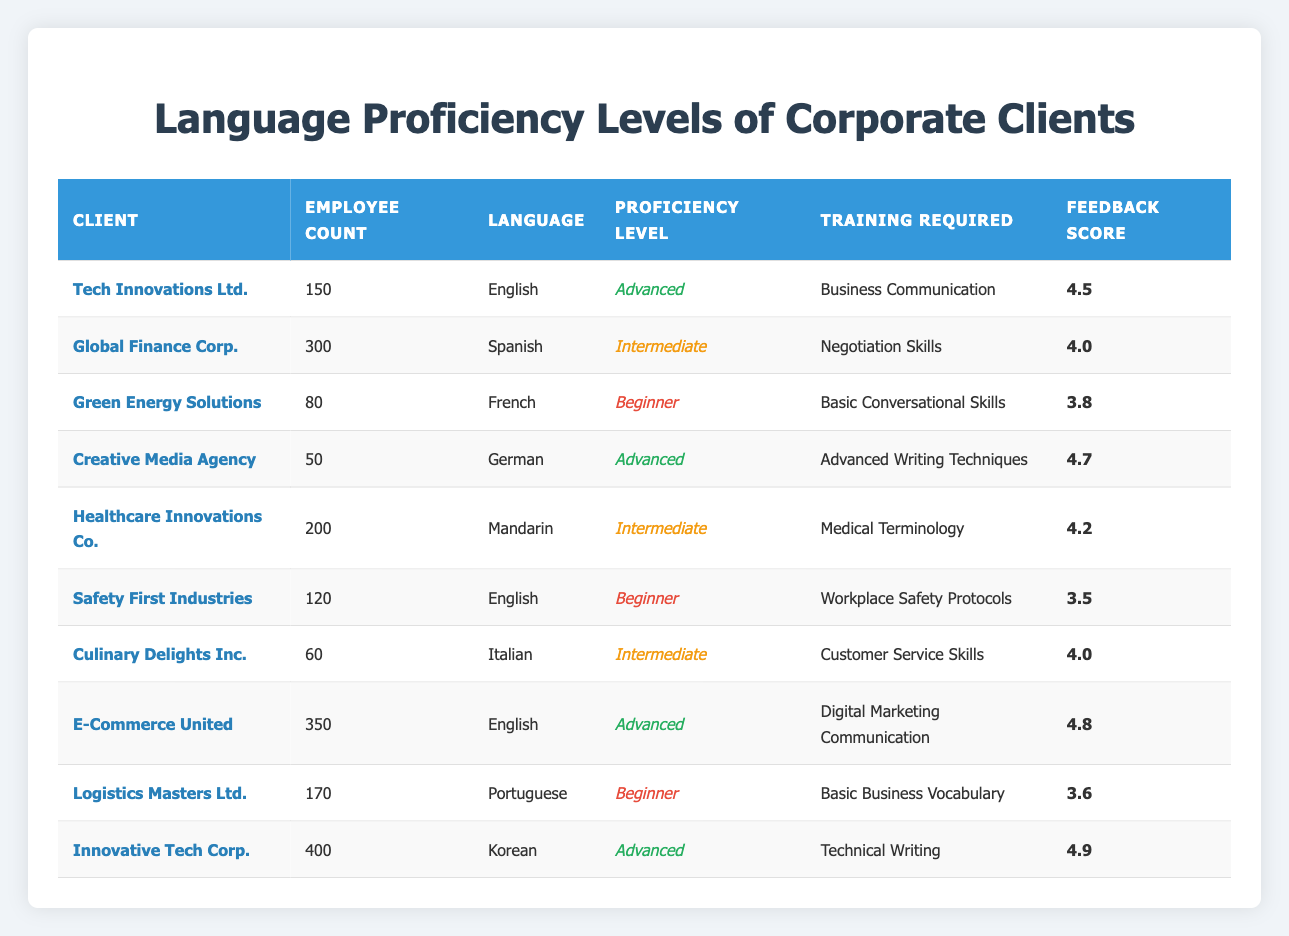What is the highest feedback score recorded in the table? Upon reviewing the feedback scores, the highest value listed is 4.9, which corresponds to Innovative Tech Corp. The scores are: 4.5, 4.0, 3.8, 4.7, 4.2, 3.5, 4.0, 4.8, 3.6, and 4.9. The maximum score among these is 4.9.
Answer: 4.9 How many clients require training for a beginner proficiency level? To determine how many clients have a beginner proficiency level, I check the proficiency levels listed for each client. The clients with a beginner proficiency are Green Energy Solutions, Safety First Industries, and Logistics Masters Ltd. That totals three clients.
Answer: 3 What is the average employee count for clients with advanced proficiency levels? The clients with advanced proficiency levels are Tech Innovations Ltd. (150), Creative Media Agency (50), E-Commerce United (350), and Innovative Tech Corp. (400). Adding these employee counts gives 150 + 50 + 350 + 400 = 950. To find the average, divide by the number of clients, which is 4. Thus, the average is 950 / 4 = 237.5.
Answer: 237.5 Is there a client whose feedback score is below 4.0? Reviewing the feedback scores, we find scores of 3.5 and 3.6 for Safety First Industries and Logistics Masters Ltd., respectively, which are both below 4.0. Therefore, the statement is true.
Answer: Yes Which language requires training on Medical Terminology, and what is the proficiency level of the corresponding client? The training required on Medical Terminology corresponds to Healthcare Innovations Co., which has an intermediate proficiency level in Mandarin. The client and its details can be directly referenced from the table.
Answer: Mandarin, Intermediate What training does E-Commerce United require, and how does its feedback score compare to the average score of clients with intermediate proficiency? E-Commerce United requires training in Digital Marketing Communication and has a feedback score of 4.8. The intermediate clients are Global Finance Corp. (4.0), Healthcare Innovations Co. (4.2), and Culinary Delights Inc. (4.0), leading to an average of (4.0 + 4.2 + 4.0) / 3 = 4.07. Comparing the scores, 4.8 is higher than 4.07.
Answer: Digital Marketing Communication, Higher How many clients are associated with the English language? Reviewing the language data, the clients associated with English are Tech Innovations Ltd. (Advanced), Safety First Industries (Beginner), and E-Commerce United (Advanced). This gives us a total of three clients.
Answer: 3 How does the proficiency level of Creative Media Agency compare to the level of clients in the medical field? Creative Media Agency has an advanced proficiency level in German. In the medical field, Healthcare Innovations Co. is an intermediate proficiency level in Mandarin. Since advanced is above intermediate, the comparison shows that Creative Media Agency is at a higher proficiency level than Healthcare Innovations Co.
Answer: Advanced is higher than Intermediate 